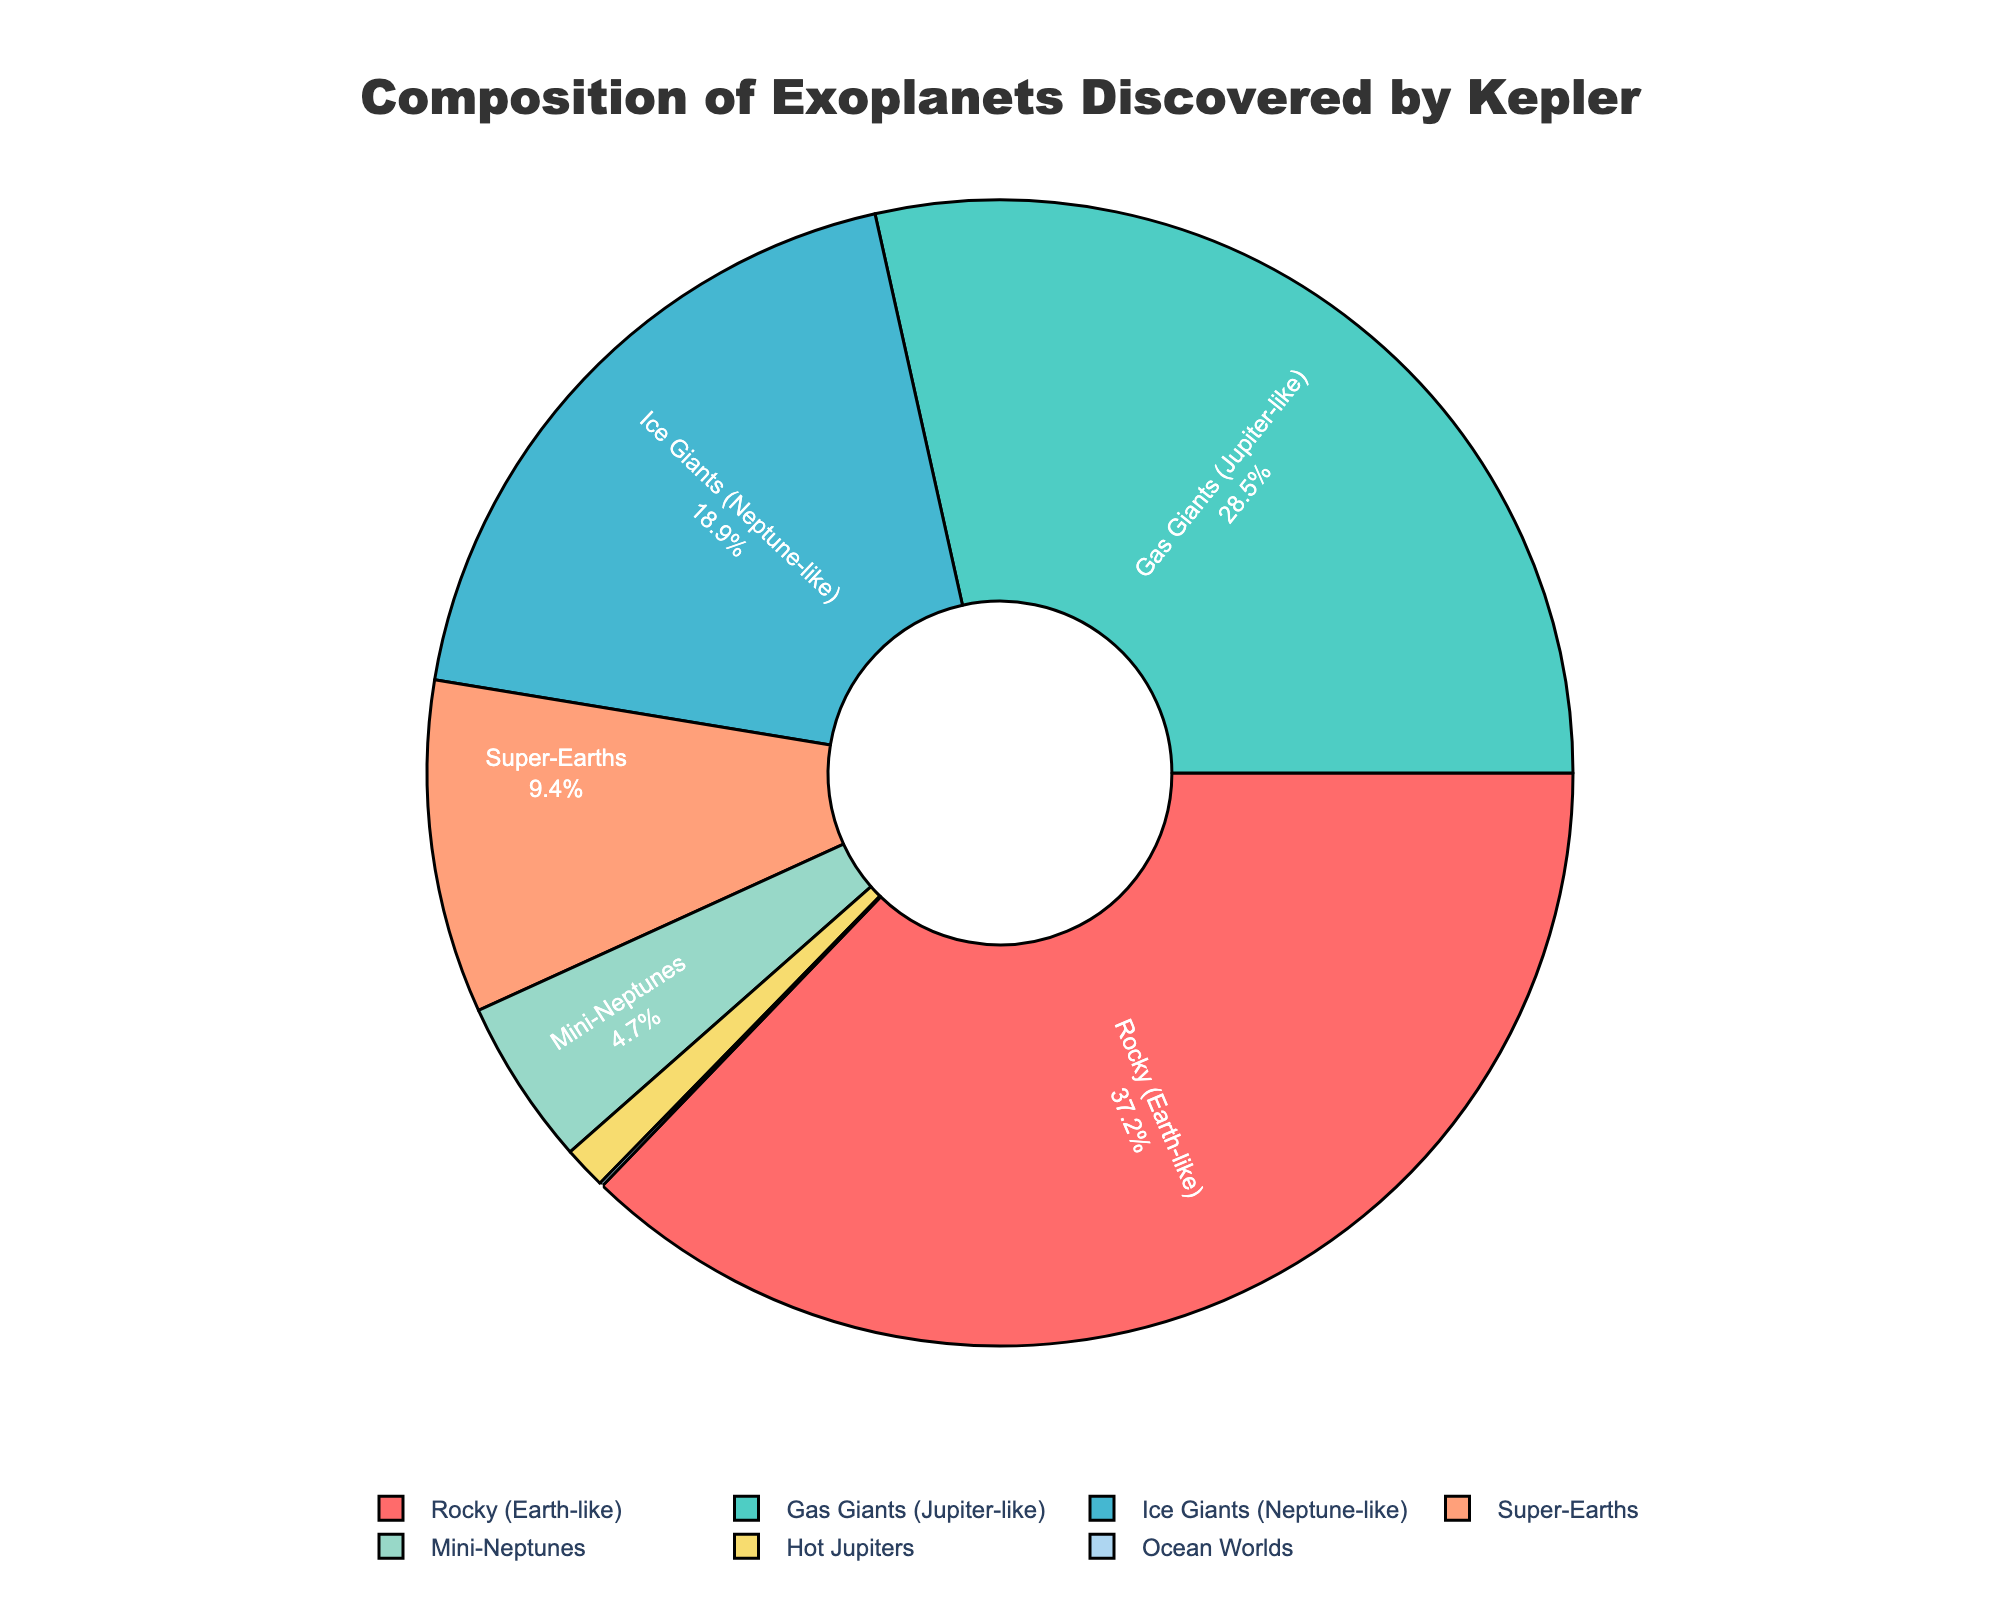What percentage of exoplanets discovered by Kepler are either Gas Giants or Rocky (Earth-like)? Adding the percentages of Gas Giants (28.5%) and Rocky (Earth-like) (37.2%) gives the total percentage for these two types. 28.5 + 37.2 = 65.7
Answer: 65.7 Which type of exoplanet has the smallest representation in the pie chart? Referring to the figure, the Ocean Worlds category has the smallest slice. This reflects a 0.1% representation.
Answer: Ocean Worlds How does the percentage of Super-Earths compare to that of Mini-Neptunes? The figure shows that Super-Earths represent 9.4%, while Mini-Neptunes represent 4.7%. Comparing the two, 9.4 is greater than 4.7.
Answer: Super-Earths have a higher percentage If you combine the percentages of Ice Giants, Super-Earths, and Mini-Neptunes, what is their total percentage? Summing the percentages of Ice Giants (18.9%), Super-Earths (9.4%), and Mini-Neptunes (4.7%) gives 18.9 + 9.4 + 4.7 = 33.0
Answer: 33.0 Which type of exoplanet shares a similar color in the chart with Hot Jupiters? By examining the chart's colors, Hot Jupiters are represented with a yellowish color. The closest in color in the figure is Ocean Worlds, which has a very light, almost yellowish hue.
Answer: Ocean Worlds Between Gas Giants and Ice Giants, which type has a larger percentage of discovered exoplanets? Referring to the percentages from the figure, Gas Giants have 28.5% while Ice Giants have 18.9%. 28.5 is greater than 18.9.
Answer: Gas Giants What is the combined percentage of all types besides Rocky (Earth-like)? Summing the percentages for all types except Rocky (Earth-like) involves: Gas Giants (28.5) + Ice Giants (18.9) + Super-Earths (9.4) + Mini-Neptunes (4.7) + Hot Jupiters (1.2) + Ocean Worlds (0.1) = 62.8
Answer: 62.8 Which compositional type has roughly a quarter of the total exoplanets discovered? Gas Giants have 28.5% representation, and a quarter of 100% is 25%, making Gas Giants the compositional type that is closest to a quarter (more so than any other types).
Answer: Gas Giants 